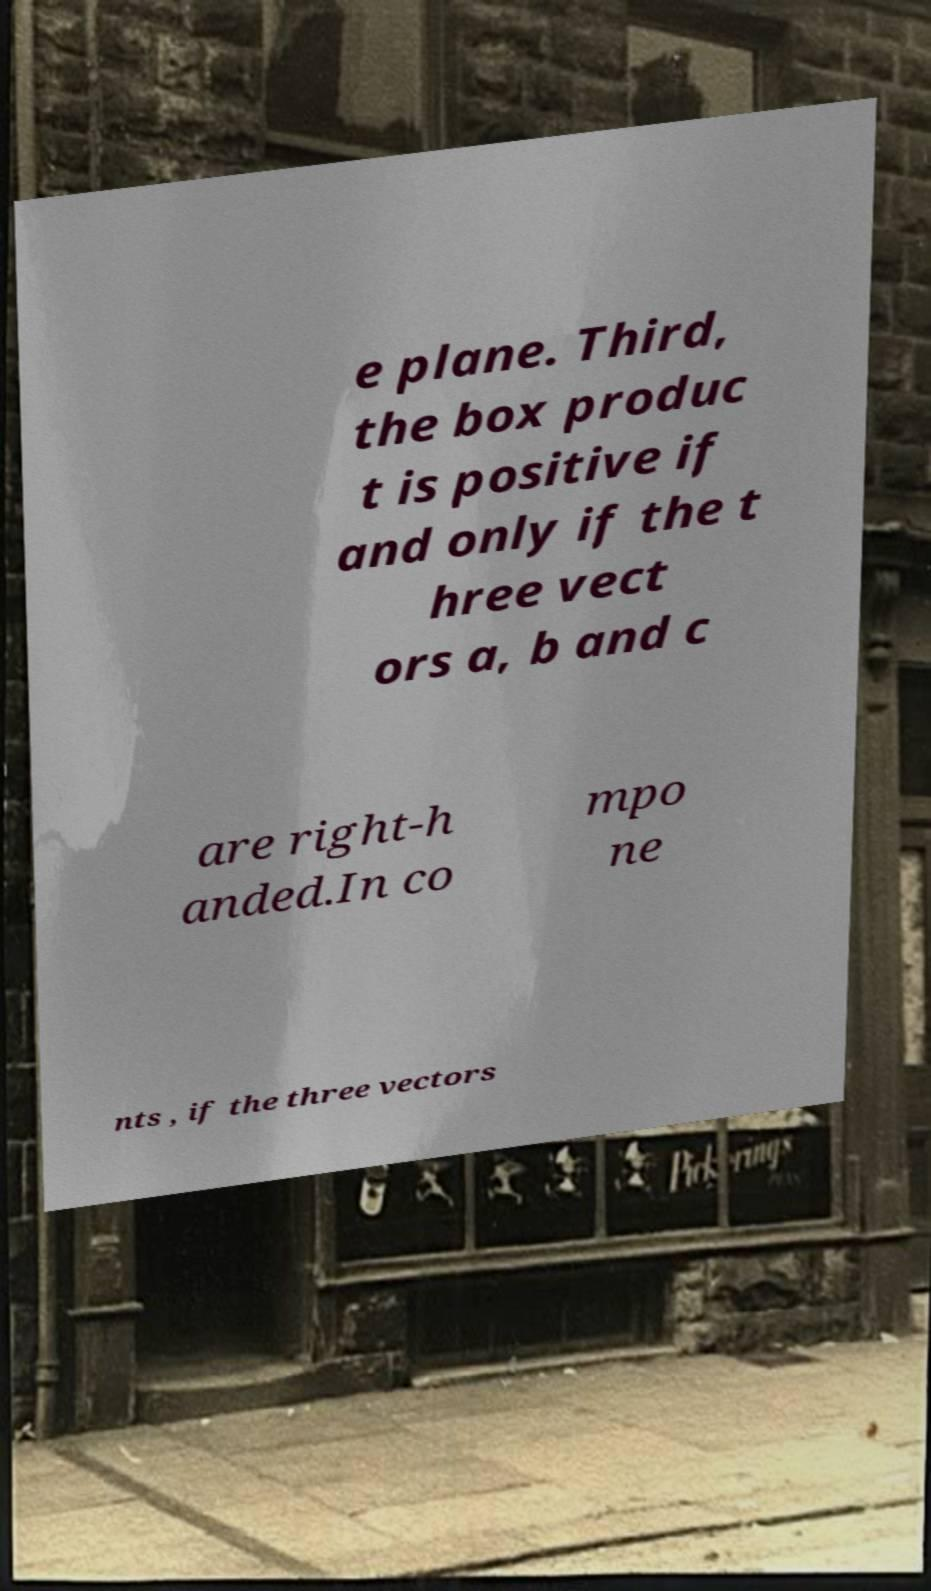Could you assist in decoding the text presented in this image and type it out clearly? e plane. Third, the box produc t is positive if and only if the t hree vect ors a, b and c are right-h anded.In co mpo ne nts , if the three vectors 